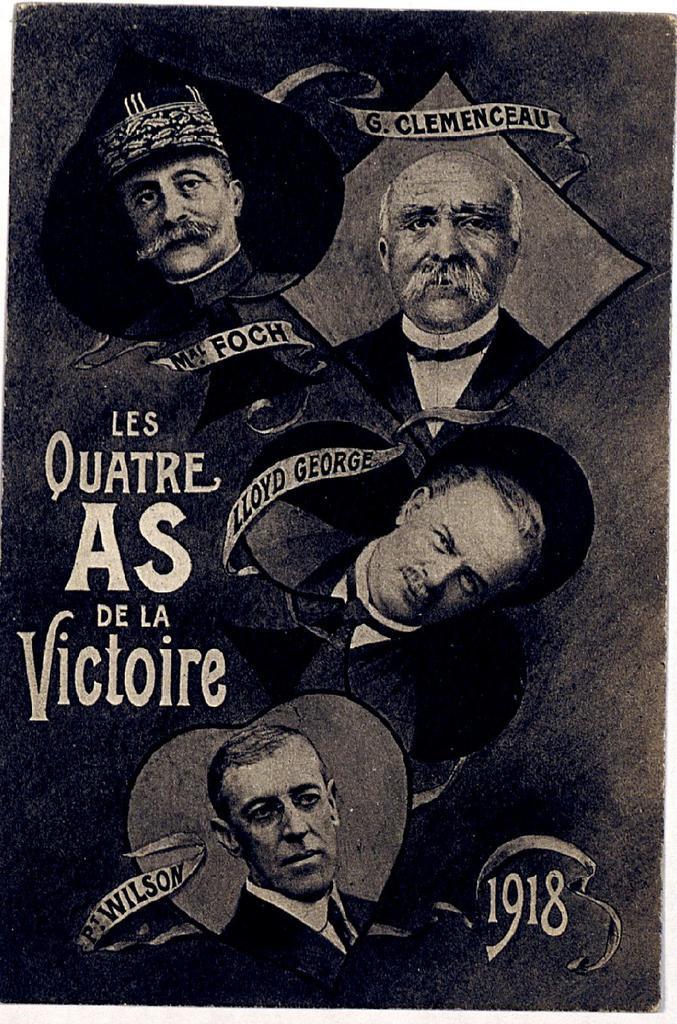Describe this image in one or two sentences. In the image we can see a poster. 